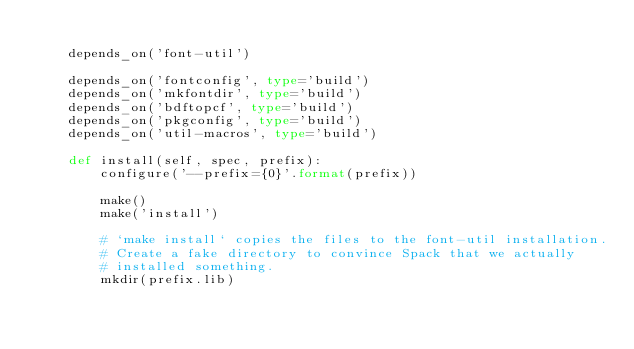Convert code to text. <code><loc_0><loc_0><loc_500><loc_500><_Python_>
    depends_on('font-util')

    depends_on('fontconfig', type='build')
    depends_on('mkfontdir', type='build')
    depends_on('bdftopcf', type='build')
    depends_on('pkgconfig', type='build')
    depends_on('util-macros', type='build')

    def install(self, spec, prefix):
        configure('--prefix={0}'.format(prefix))

        make()
        make('install')

        # `make install` copies the files to the font-util installation.
        # Create a fake directory to convince Spack that we actually
        # installed something.
        mkdir(prefix.lib)
</code> 